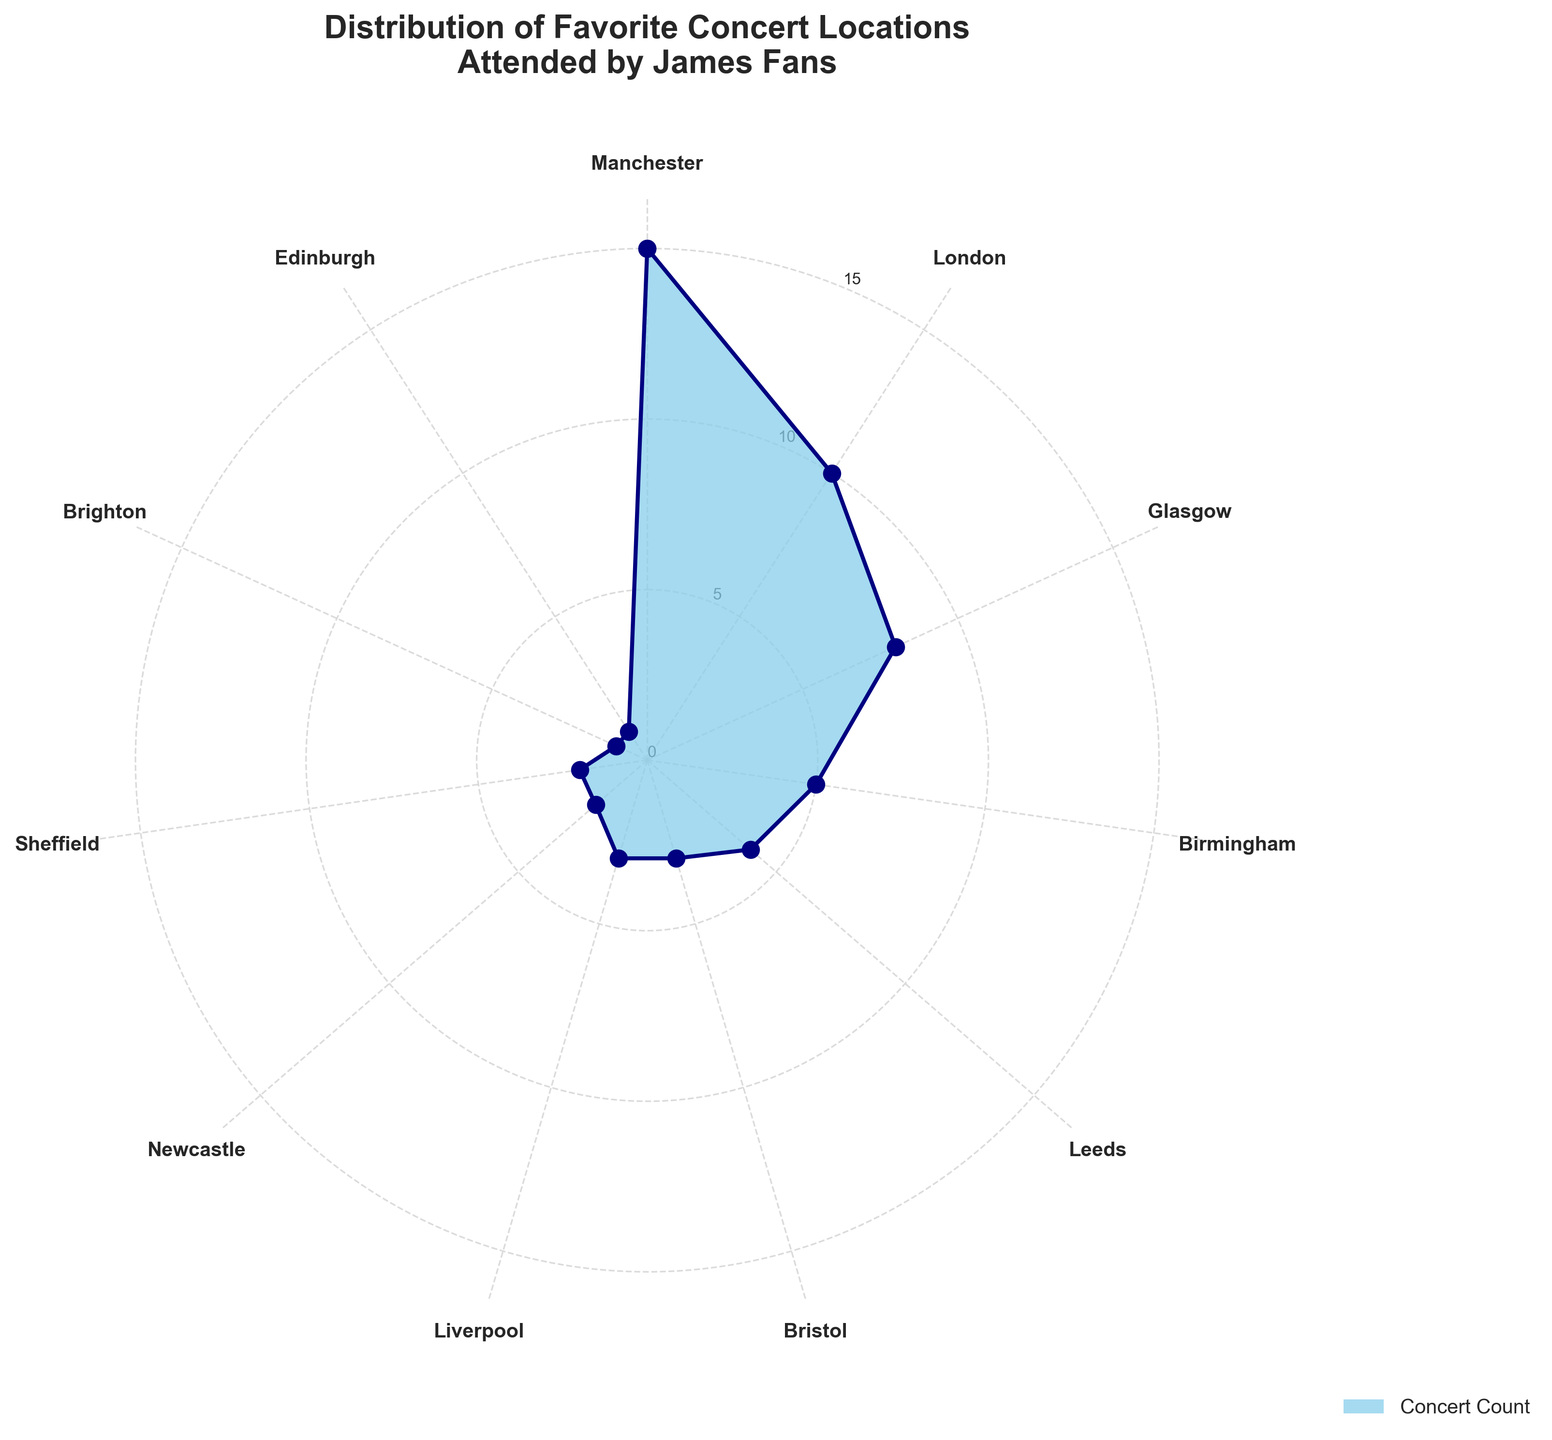What is the title of the figure? The title is typically found at the top of the figure, indicating what the chart is about. In this case, the title is prominently displayed.
Answer: Distribution of Favorite Concert Locations Attended by James Fans Which location has the highest concert count? To find the location with the highest concert count, look for the longest segment in the polar area chart. The location label on the longest segment indicates the highest count.
Answer: Manchester How many favorite concert locations have a count of 3 or less? Identify the segments in the chart with values of 3 or lower and count them. These segments are smaller in size compared to others.
Answer: 4 What is the combined concert count for Liverpool and Bristol? To find this, add the concert counts for Liverpool and Bristol. Look at the chart to identify the segments corresponding to these locations and sum their values. Liverpool has 3, and Bristol has 3, so \( 3 + 3 = 6 \).
Answer: 6 What percentage of the total concert count is from London? First, sum the concert counts of all locations. Then, divide London's concert count by the total and multiply by 100 to get the percentage. The total count is 54, and London has 10, so \( (10 / 54) \times 100 \approx 18.52%\).
Answer: 18.52% Which locations have an equal concert count? Look for segments in the chart that are of equal length. Both Liverpool and Bristol have a count of 3, and Newcastle and Sheffield both have a count of 2.
Answer: Liverpool & Bristol, Newcastle & Sheffield How many locations have a concert count greater than 5? Count the number of segments where the concert count is greater than 5. These segments are longer and more prominent.
Answer: 3 (Manchester, London, Glasgow) What is the difference in concert count between Manchester and Edinburgh? Subtract the concert count of Edinburgh from Manchester. Manchester has the highest count, so \( 15 - 1 = 14 \).
Answer: 14 Which location has the smallest concert count, and what is it? Identify the shortest segment in the chart. The label on this segment indicates the location with the smallest count.
Answer: Brighton and Edinburgh, 1 concert each 